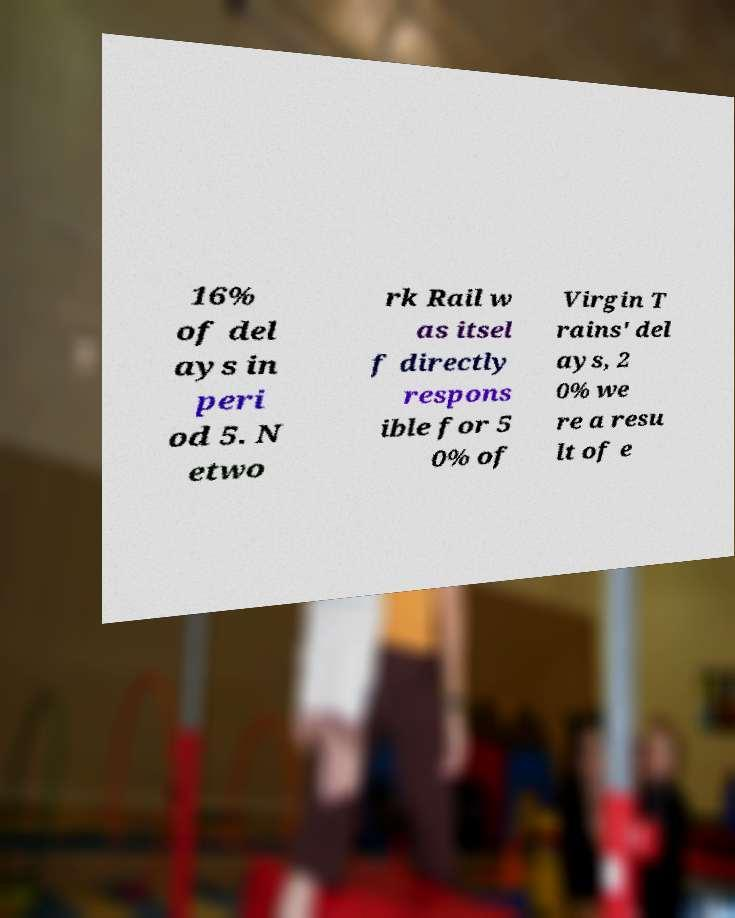Please read and relay the text visible in this image. What does it say? 16% of del ays in peri od 5. N etwo rk Rail w as itsel f directly respons ible for 5 0% of Virgin T rains' del ays, 2 0% we re a resu lt of e 